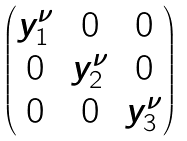Convert formula to latex. <formula><loc_0><loc_0><loc_500><loc_500>\begin{pmatrix} y _ { 1 } ^ { \nu } & 0 & 0 \\ 0 & y _ { 2 } ^ { \nu } & 0 \\ 0 & 0 & y _ { 3 } ^ { \nu } \end{pmatrix}</formula> 